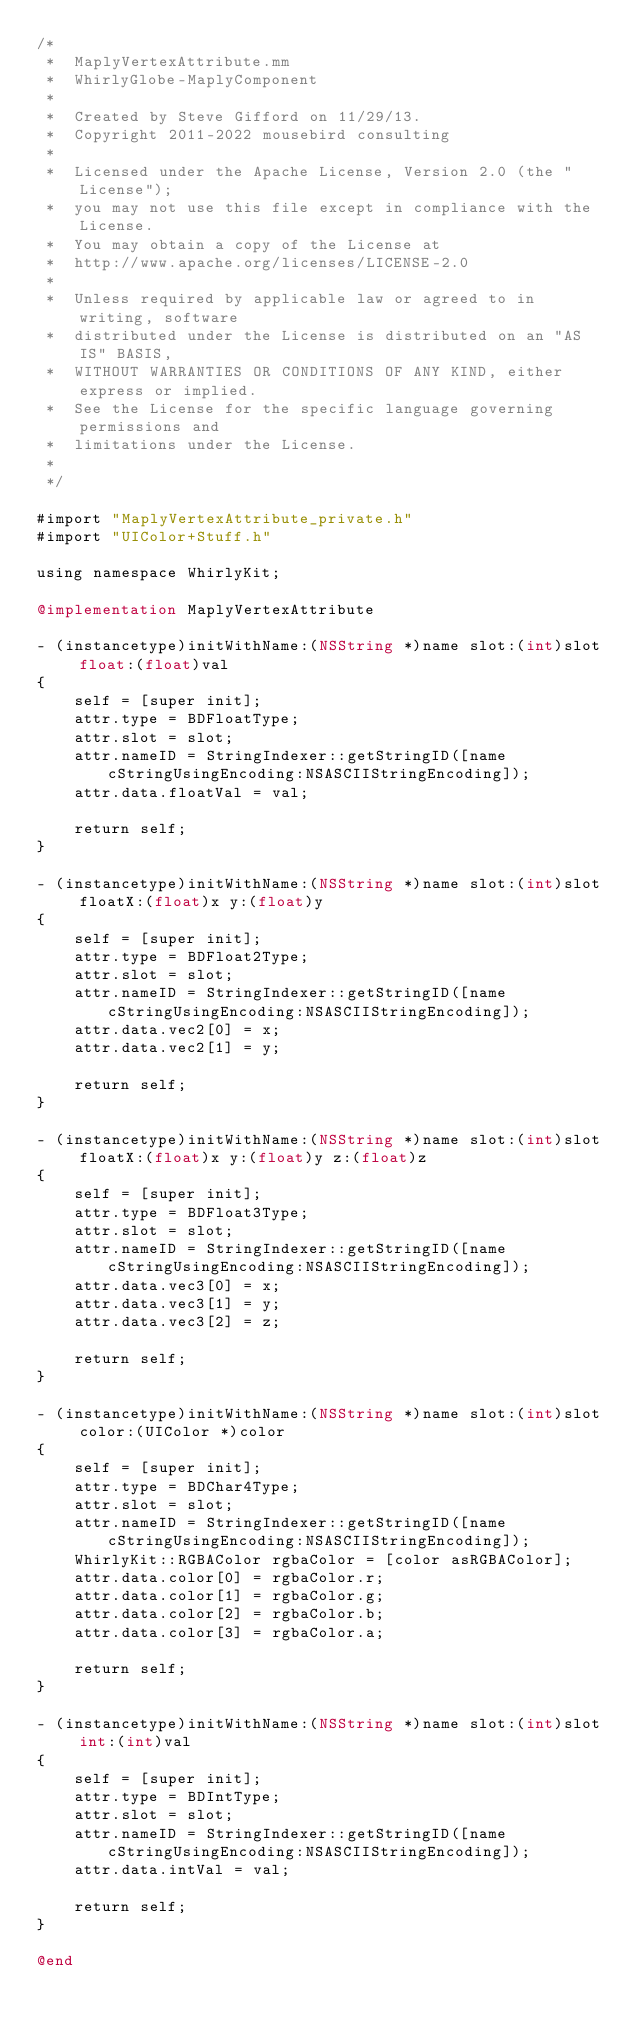<code> <loc_0><loc_0><loc_500><loc_500><_ObjectiveC_>/*
 *  MaplyVertexAttribute.mm
 *  WhirlyGlobe-MaplyComponent
 *
 *  Created by Steve Gifford on 11/29/13.
 *  Copyright 2011-2022 mousebird consulting
 *
 *  Licensed under the Apache License, Version 2.0 (the "License");
 *  you may not use this file except in compliance with the License.
 *  You may obtain a copy of the License at
 *  http://www.apache.org/licenses/LICENSE-2.0
 *
 *  Unless required by applicable law or agreed to in writing, software
 *  distributed under the License is distributed on an "AS IS" BASIS,
 *  WITHOUT WARRANTIES OR CONDITIONS OF ANY KIND, either express or implied.
 *  See the License for the specific language governing permissions and
 *  limitations under the License.
 *
 */

#import "MaplyVertexAttribute_private.h"
#import "UIColor+Stuff.h"

using namespace WhirlyKit;

@implementation MaplyVertexAttribute

- (instancetype)initWithName:(NSString *)name slot:(int)slot float:(float)val
{
    self = [super init];
    attr.type = BDFloatType;
    attr.slot = slot;
    attr.nameID = StringIndexer::getStringID([name cStringUsingEncoding:NSASCIIStringEncoding]);
    attr.data.floatVal = val;
    
    return self;
}

- (instancetype)initWithName:(NSString *)name slot:(int)slot floatX:(float)x y:(float)y
{
    self = [super init];
    attr.type = BDFloat2Type;
    attr.slot = slot;
    attr.nameID = StringIndexer::getStringID([name cStringUsingEncoding:NSASCIIStringEncoding]);
    attr.data.vec2[0] = x;
    attr.data.vec2[1] = y;
    
    return self;
}

- (instancetype)initWithName:(NSString *)name slot:(int)slot floatX:(float)x y:(float)y z:(float)z
{
    self = [super init];
    attr.type = BDFloat3Type;
    attr.slot = slot;
    attr.nameID = StringIndexer::getStringID([name cStringUsingEncoding:NSASCIIStringEncoding]);
    attr.data.vec3[0] = x;
    attr.data.vec3[1] = y;
    attr.data.vec3[2] = z;
    
    return self;
}

- (instancetype)initWithName:(NSString *)name slot:(int)slot color:(UIColor *)color
{
    self = [super init];
    attr.type = BDChar4Type;
    attr.slot = slot;
    attr.nameID = StringIndexer::getStringID([name cStringUsingEncoding:NSASCIIStringEncoding]);
    WhirlyKit::RGBAColor rgbaColor = [color asRGBAColor];
    attr.data.color[0] = rgbaColor.r;
    attr.data.color[1] = rgbaColor.g;
    attr.data.color[2] = rgbaColor.b;
    attr.data.color[3] = rgbaColor.a;
    
    return self;
}

- (instancetype)initWithName:(NSString *)name slot:(int)slot int:(int)val
{
    self = [super init];
    attr.type = BDIntType;
    attr.slot = slot;
    attr.nameID = StringIndexer::getStringID([name cStringUsingEncoding:NSASCIIStringEncoding]);
    attr.data.intVal = val;
    
    return self;
}

@end
</code> 